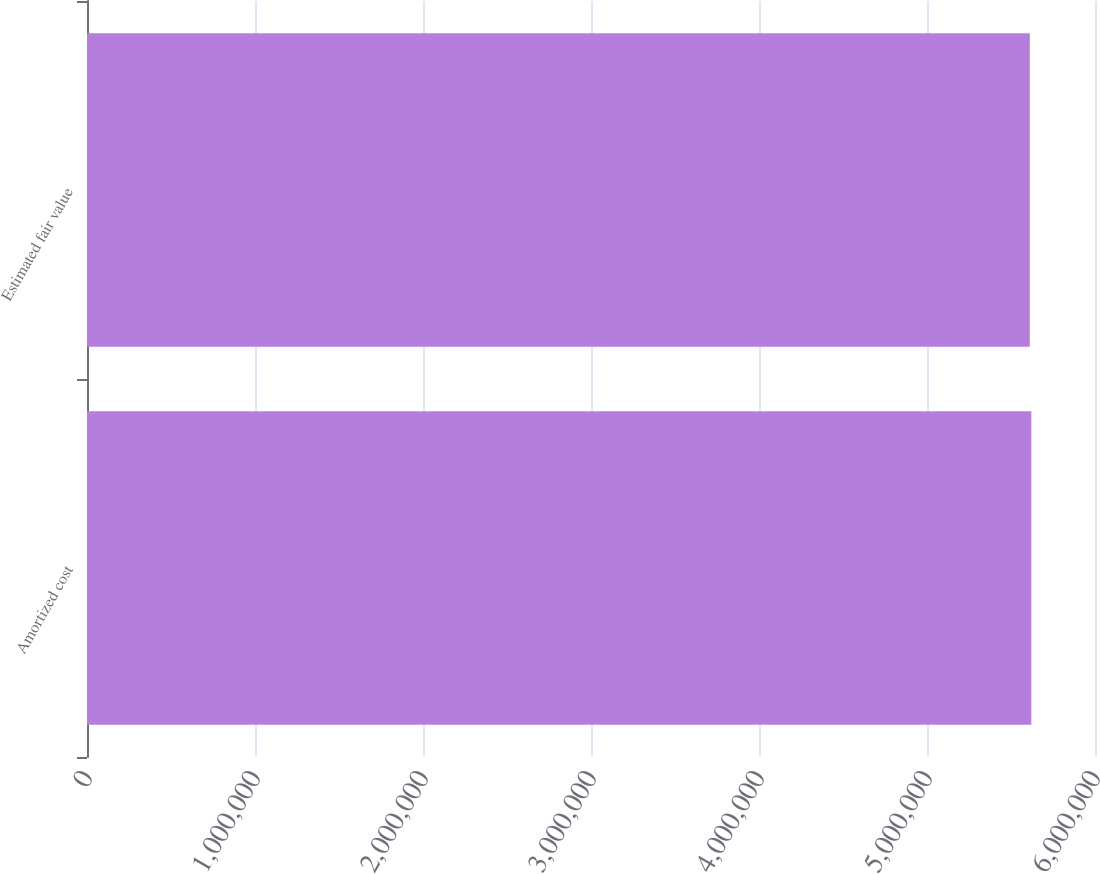Convert chart. <chart><loc_0><loc_0><loc_500><loc_500><bar_chart><fcel>Amortized cost<fcel>Estimated fair value<nl><fcel>5.62097e+06<fcel>5.61197e+06<nl></chart> 